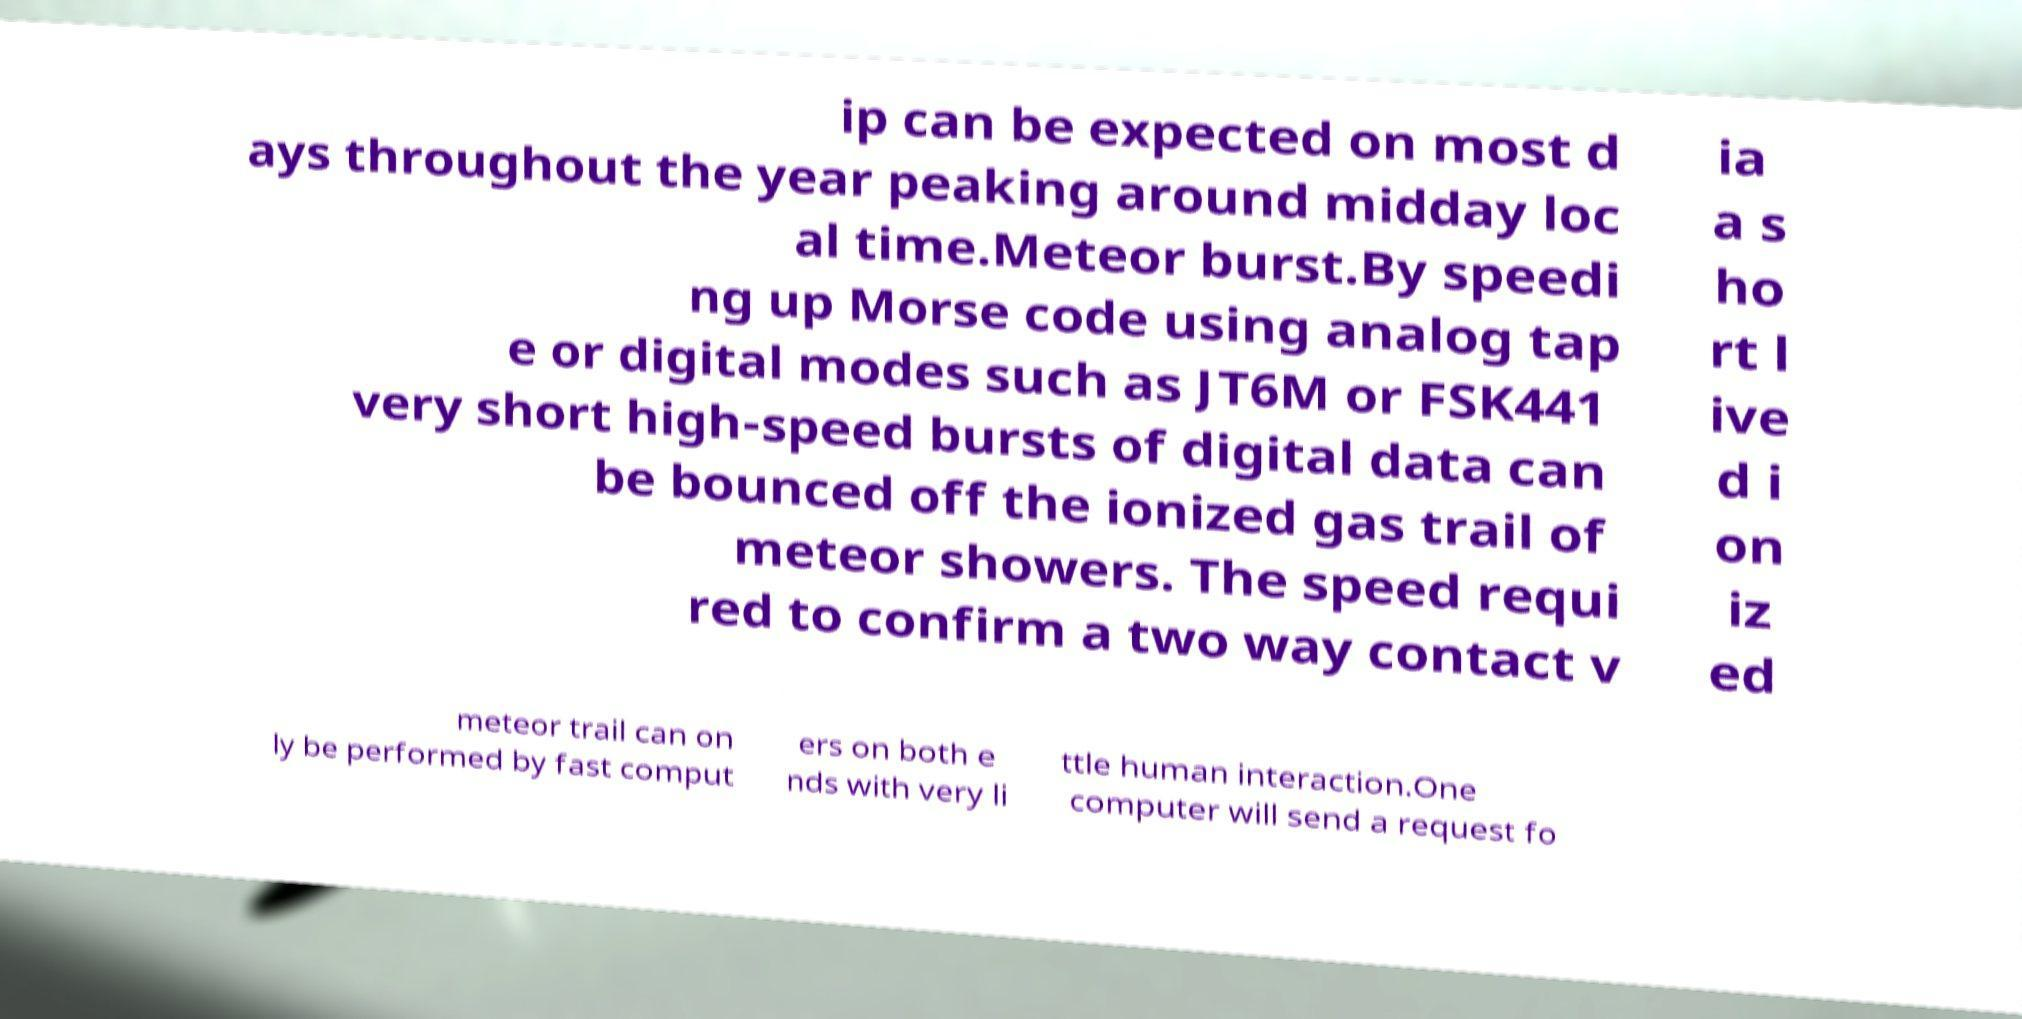Please read and relay the text visible in this image. What does it say? ip can be expected on most d ays throughout the year peaking around midday loc al time.Meteor burst.By speedi ng up Morse code using analog tap e or digital modes such as JT6M or FSK441 very short high-speed bursts of digital data can be bounced off the ionized gas trail of meteor showers. The speed requi red to confirm a two way contact v ia a s ho rt l ive d i on iz ed meteor trail can on ly be performed by fast comput ers on both e nds with very li ttle human interaction.One computer will send a request fo 